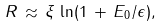<formula> <loc_0><loc_0><loc_500><loc_500>R \, \approx \, \xi \, \ln ( 1 \, + \, E _ { 0 } / \epsilon ) ,</formula> 